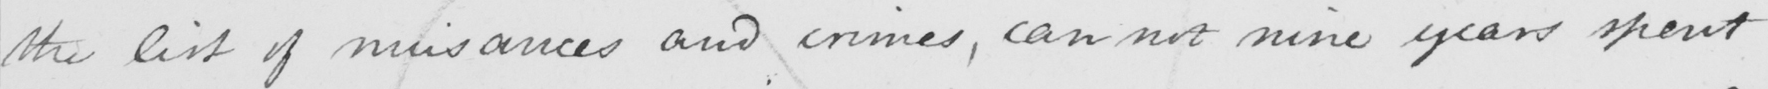Can you tell me what this handwritten text says? the list of nuisances and crimes , can not nine years spent 